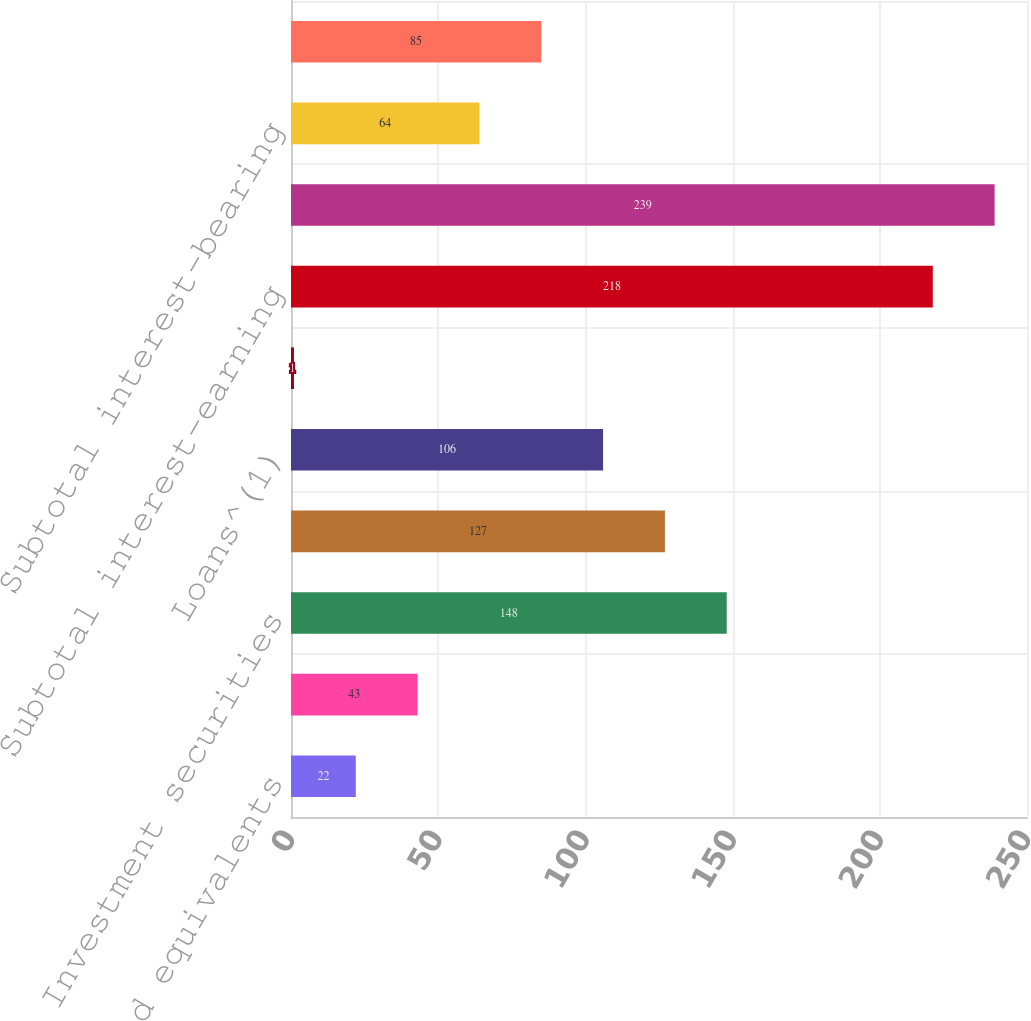Convert chart. <chart><loc_0><loc_0><loc_500><loc_500><bar_chart><fcel>Cash and equivalents<fcel>Cash segregated under federal<fcel>Investment securities<fcel>Margin receivables<fcel>Loans^(1)<fcel>Broker-related receivables and<fcel>Subtotal interest-earning<fcel>Total interest-earning assets<fcel>Subtotal interest-bearing<fcel>Total interest-bearing<nl><fcel>22<fcel>43<fcel>148<fcel>127<fcel>106<fcel>1<fcel>218<fcel>239<fcel>64<fcel>85<nl></chart> 